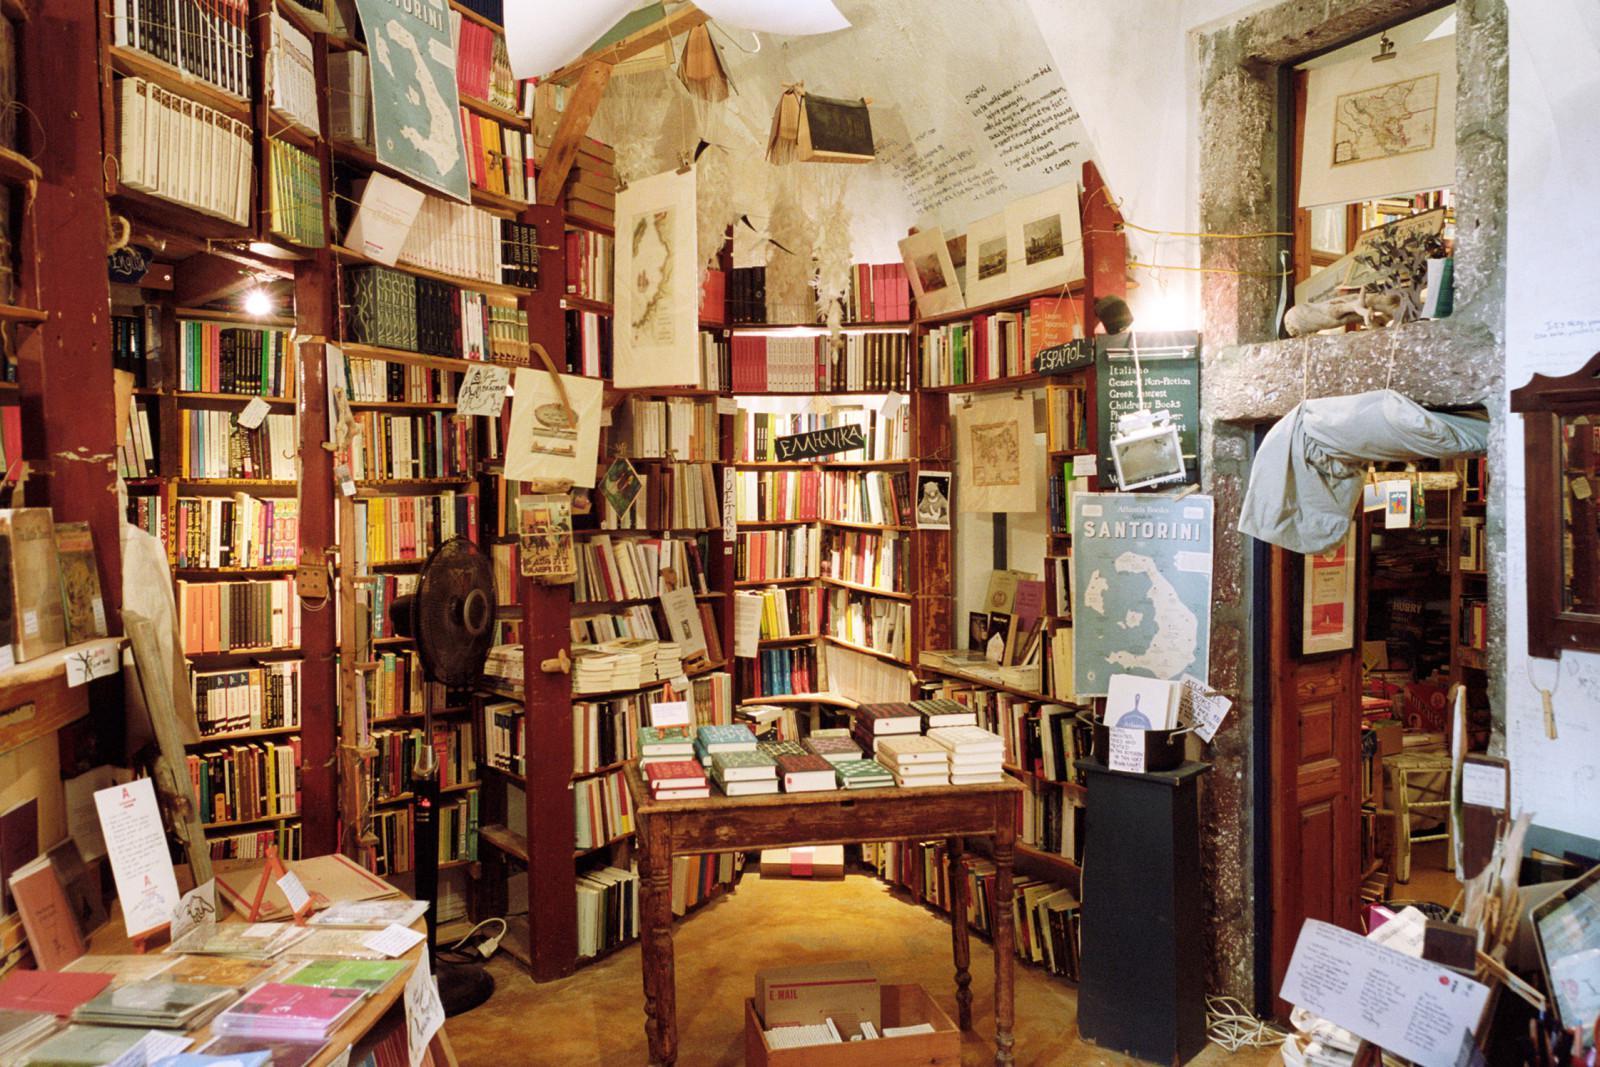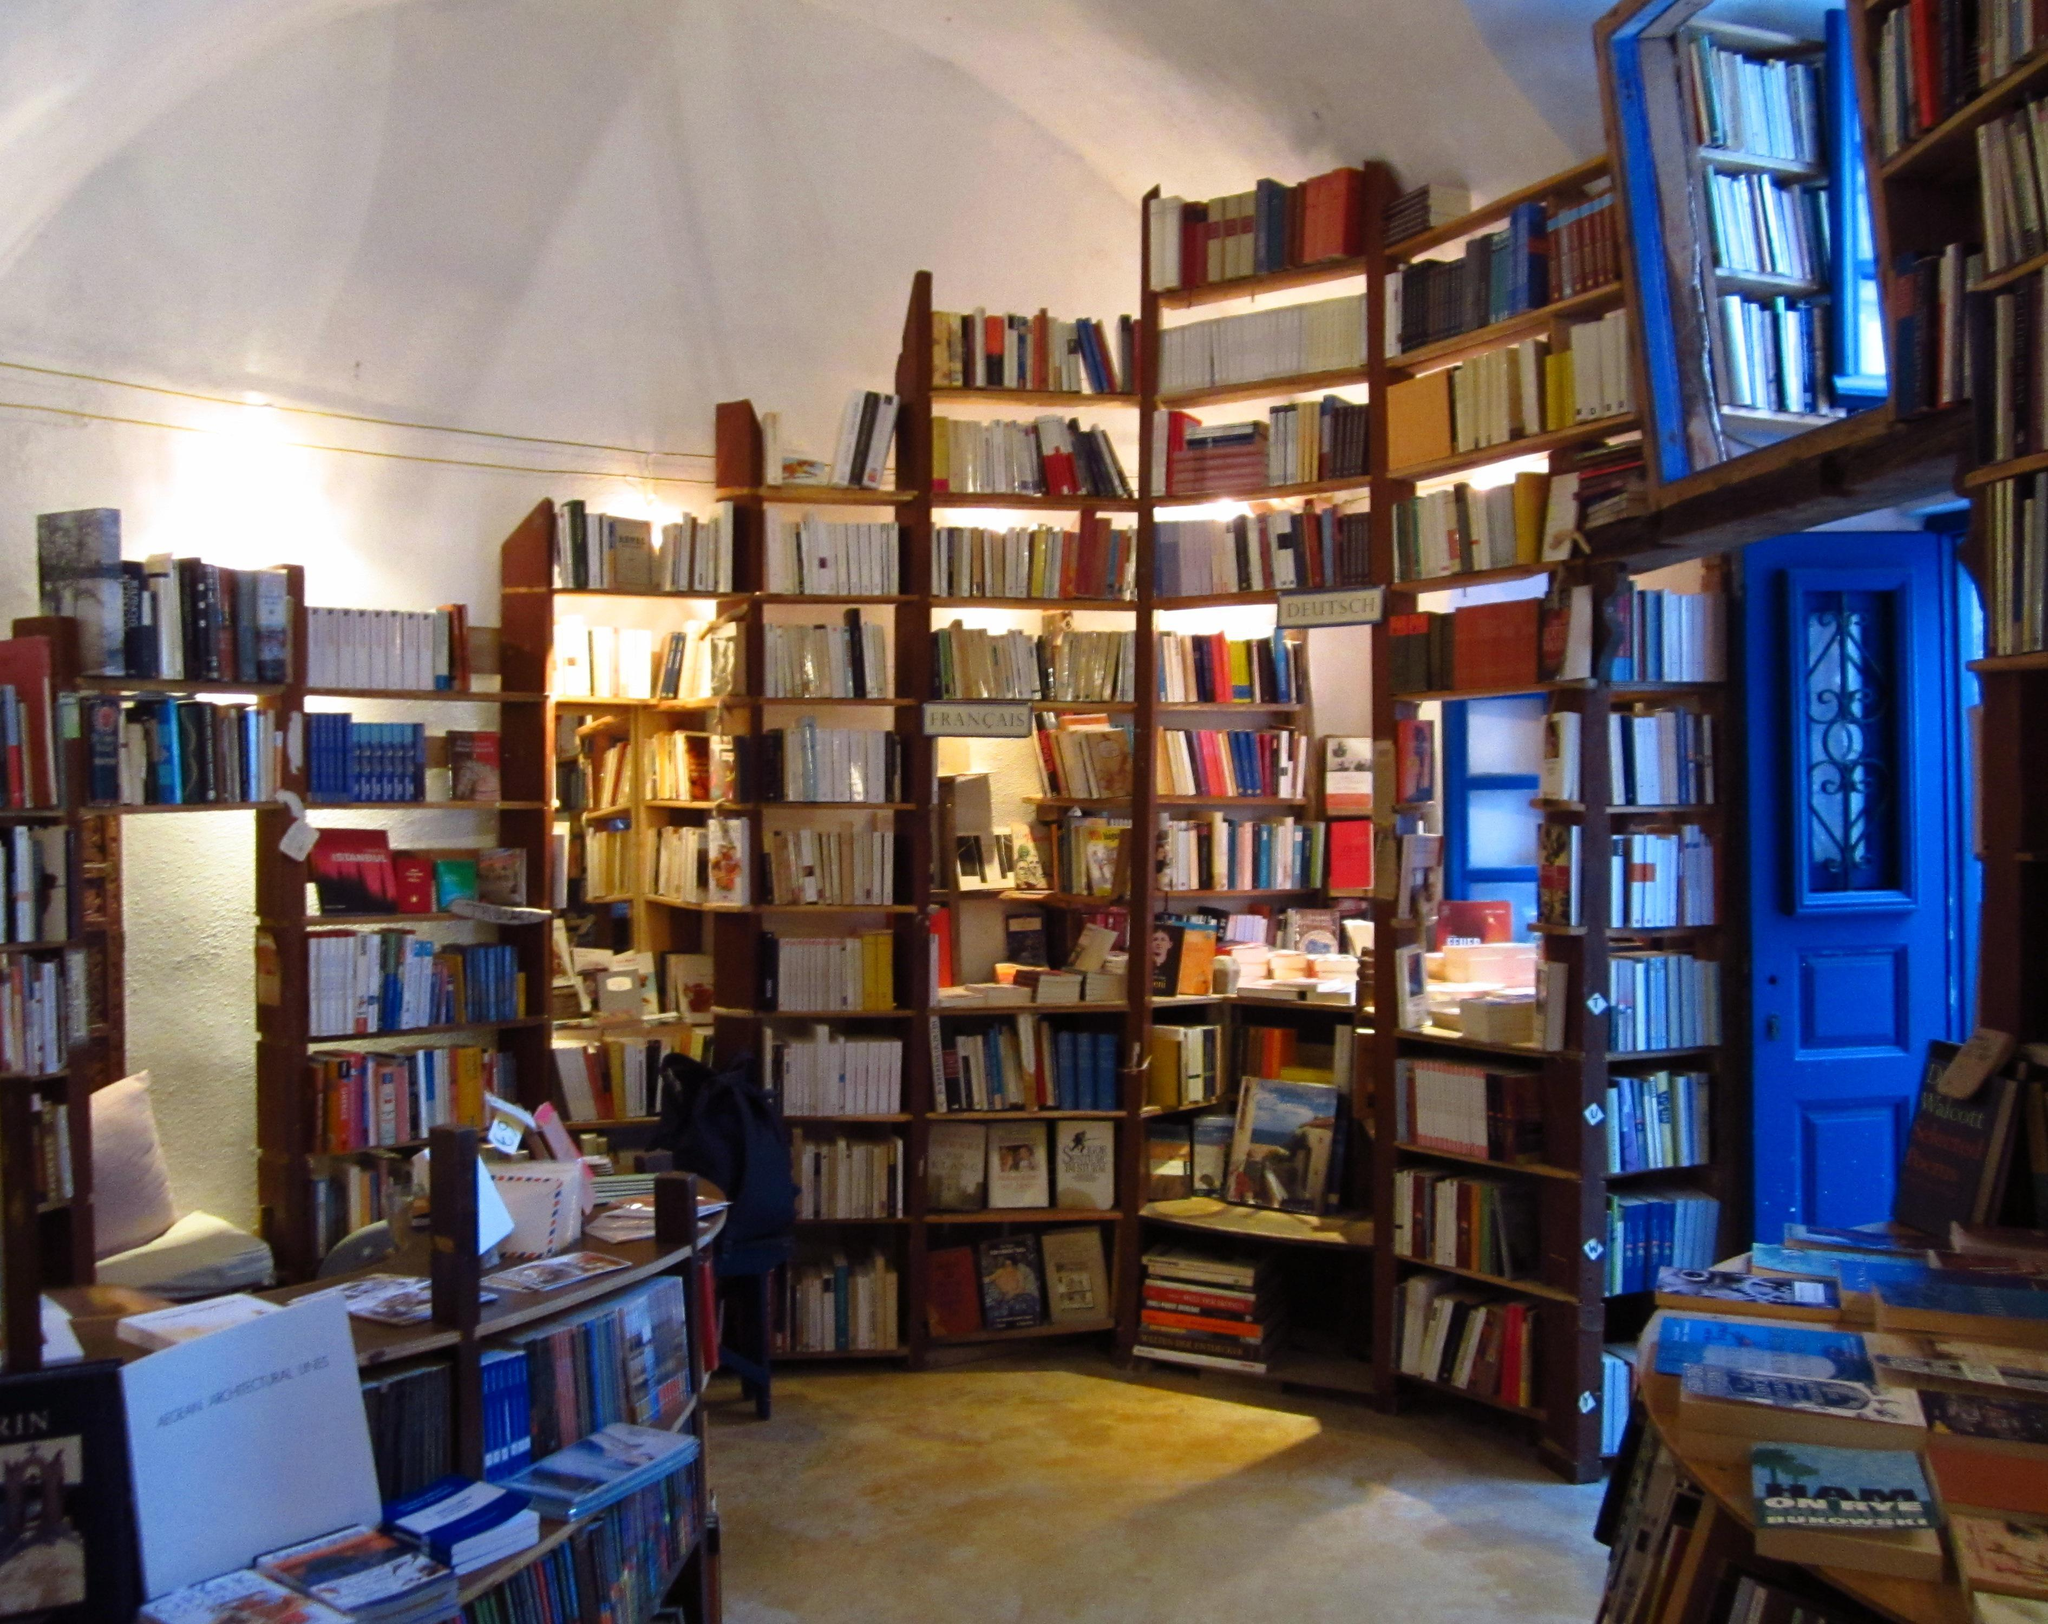The first image is the image on the left, the second image is the image on the right. For the images displayed, is the sentence "At least one person is near the bookstore in one of the images." factually correct? Answer yes or no. No. The first image is the image on the left, the second image is the image on the right. Given the left and right images, does the statement "An image of a room lined with shelves of books includes a stringed instrument near the center of the picture." hold true? Answer yes or no. No. 